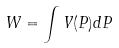<formula> <loc_0><loc_0><loc_500><loc_500>W = \int V ( P ) d P</formula> 